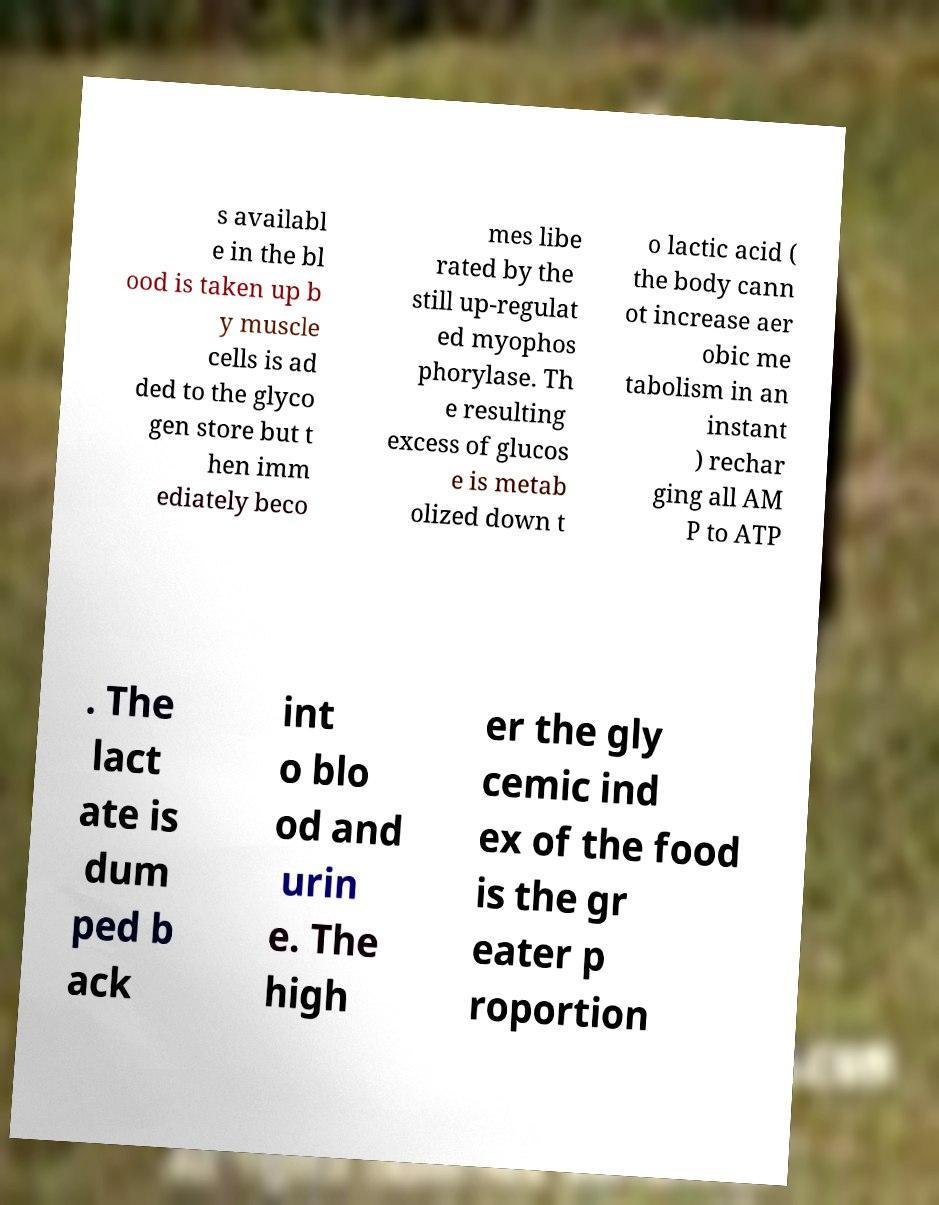For documentation purposes, I need the text within this image transcribed. Could you provide that? s availabl e in the bl ood is taken up b y muscle cells is ad ded to the glyco gen store but t hen imm ediately beco mes libe rated by the still up-regulat ed myophos phorylase. Th e resulting excess of glucos e is metab olized down t o lactic acid ( the body cann ot increase aer obic me tabolism in an instant ) rechar ging all AM P to ATP . The lact ate is dum ped b ack int o blo od and urin e. The high er the gly cemic ind ex of the food is the gr eater p roportion 